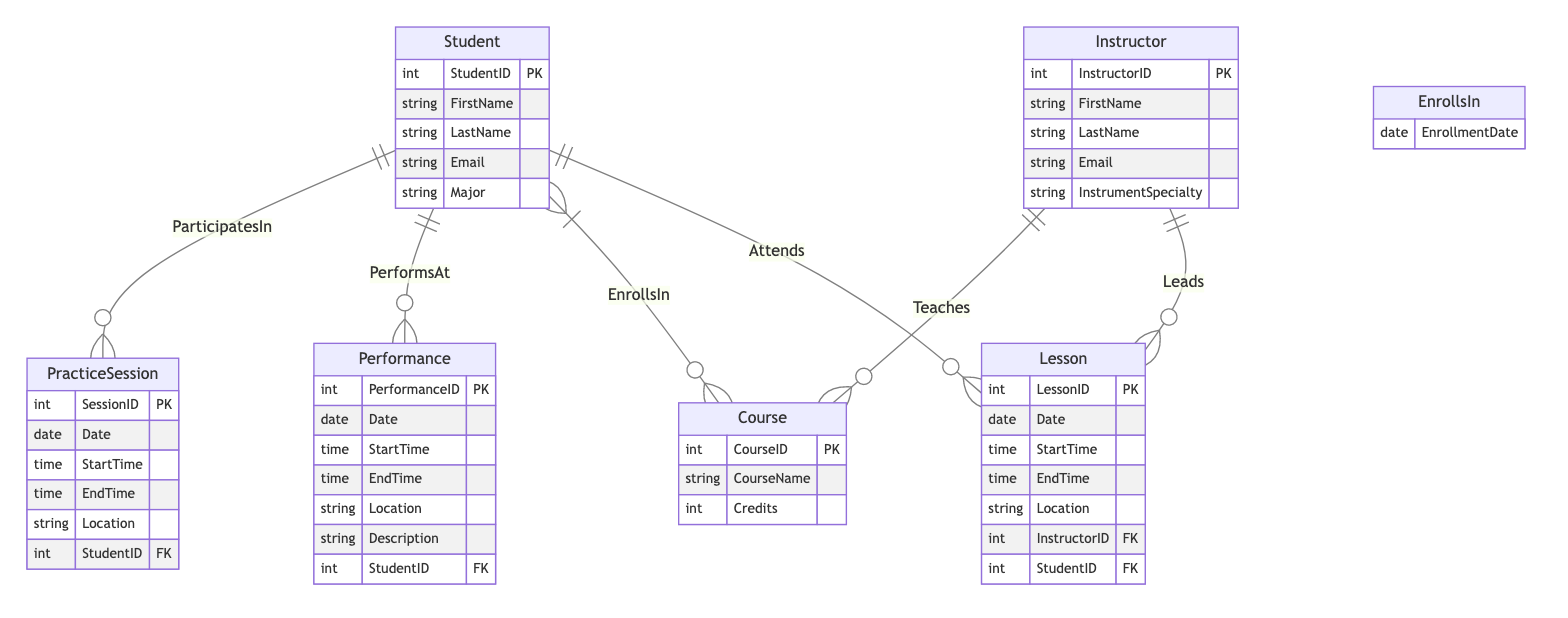What entities are included in this diagram? The diagram shows six entities: Student, Instructor, PracticeSession, Performance, Lesson, and Course.
Answer: Student, Instructor, PracticeSession, Performance, Lesson, Course How many attributes does the Student entity have? The Student entity has five attributes: StudentID, FirstName, LastName, Email, and Major.
Answer: Five What relationship exists between the Instructor and Course entities? The relationship between Instructor and Course is named "Teaches," which indicates that an instructor can teach multiple courses.
Answer: Teaches How many relationships involve the Student entity? The Student entity is involved in five relationships: ParticipatesIn, PerformsAt, EnrollsIn, Attends, and has one from the Lessons entity.
Answer: Five Which entity has a one-to-many relationship with the Lesson entity? The Instructor entity has a one-to-many relationship with the Lesson entity, as each instructor can lead multiple lessons.
Answer: Instructor In the EnrollsIn relationship, what additional attribute is included? The EnrollsIn relationship includes an additional attribute called EnrollmentDate, which captures the date when the student enrolled in the course.
Answer: EnrollmentDate How many unique roles do instructors have in this diagram? Instructors have two unique roles in this diagram: as teachers of courses and as leaders of lessons.
Answer: Two What is the primary key for the Performance entity? The primary key for the Performance entity is PerformanceID, which uniquely identifies each performance record in the database.
Answer: PerformanceID 